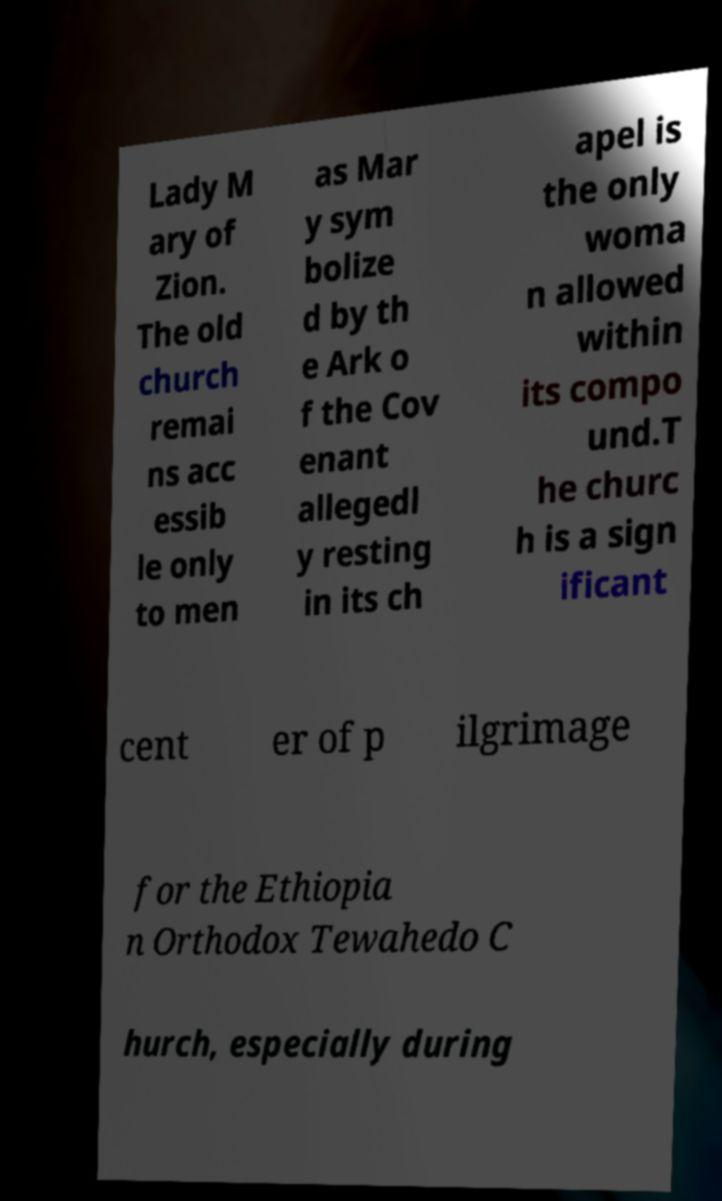For documentation purposes, I need the text within this image transcribed. Could you provide that? Lady M ary of Zion. The old church remai ns acc essib le only to men as Mar y sym bolize d by th e Ark o f the Cov enant allegedl y resting in its ch apel is the only woma n allowed within its compo und.T he churc h is a sign ificant cent er of p ilgrimage for the Ethiopia n Orthodox Tewahedo C hurch, especially during 